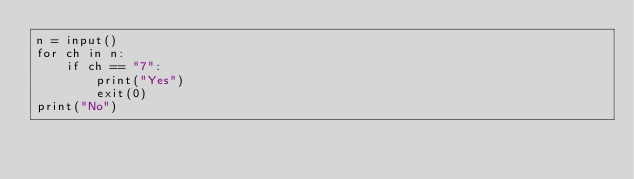<code> <loc_0><loc_0><loc_500><loc_500><_Python_>n = input()
for ch in n:
    if ch == "7":
        print("Yes")
        exit(0)
print("No")
</code> 